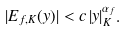<formula> <loc_0><loc_0><loc_500><loc_500>| E _ { f , K } ( y ) | < c \, | y | _ { K } ^ { \alpha _ { f } } .</formula> 